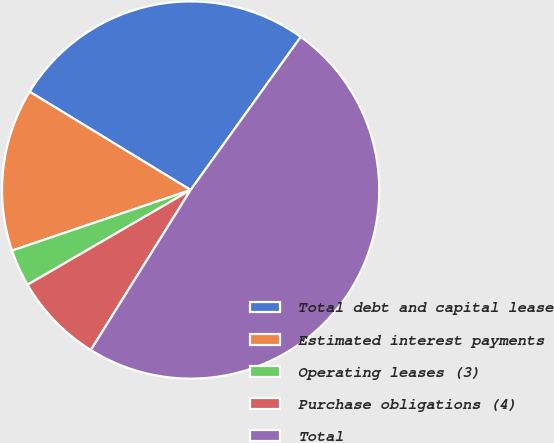Convert chart to OTSL. <chart><loc_0><loc_0><loc_500><loc_500><pie_chart><fcel>Total debt and capital lease<fcel>Estimated interest payments<fcel>Operating leases (3)<fcel>Purchase obligations (4)<fcel>Total<nl><fcel>26.2%<fcel>13.93%<fcel>3.17%<fcel>7.75%<fcel>48.95%<nl></chart> 